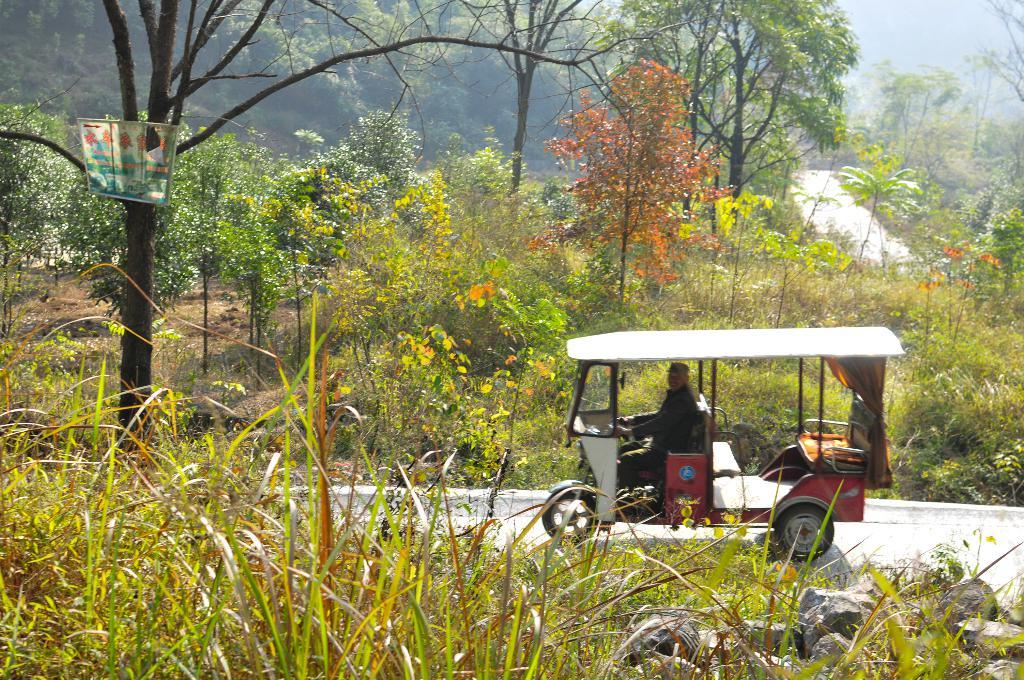What is the person in the image doing? There is a person riding a vehicle on the road in the image. What type of natural elements can be seen in the image? Plants and trees are visible in the image. What can be seen in the distance in the image? There are mountains in the background of the image. How many quince are hanging from the trees in the image? There are no quince visible in the image; only trees are present. What type of base is supporting the vehicle in the image? The image does not show the base of the vehicle, as it only depicts the person riding it on the road. 